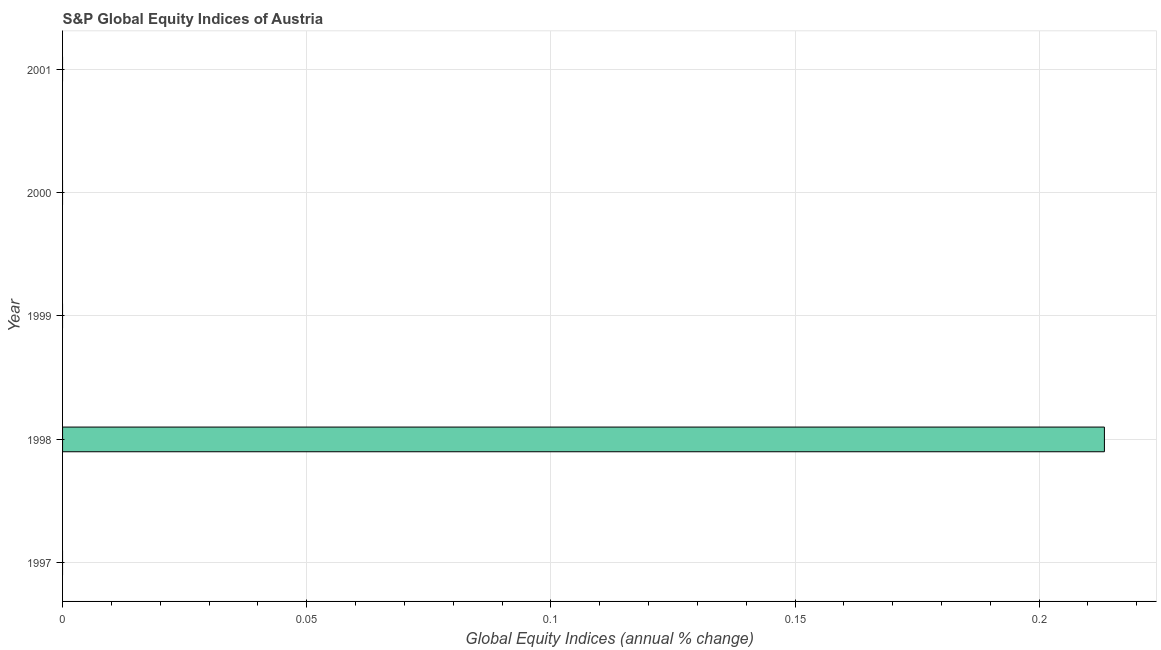What is the title of the graph?
Ensure brevity in your answer.  S&P Global Equity Indices of Austria. What is the label or title of the X-axis?
Provide a short and direct response. Global Equity Indices (annual % change). What is the s&p global equity indices in 2001?
Make the answer very short. 0. Across all years, what is the maximum s&p global equity indices?
Give a very brief answer. 0.21. Across all years, what is the minimum s&p global equity indices?
Your answer should be very brief. 0. What is the sum of the s&p global equity indices?
Provide a succinct answer. 0.21. What is the average s&p global equity indices per year?
Ensure brevity in your answer.  0.04. What is the difference between the highest and the lowest s&p global equity indices?
Provide a short and direct response. 0.21. How many bars are there?
Provide a succinct answer. 1. Are the values on the major ticks of X-axis written in scientific E-notation?
Offer a very short reply. No. What is the Global Equity Indices (annual % change) in 1997?
Your response must be concise. 0. What is the Global Equity Indices (annual % change) of 1998?
Offer a very short reply. 0.21. What is the Global Equity Indices (annual % change) of 2000?
Provide a short and direct response. 0. 